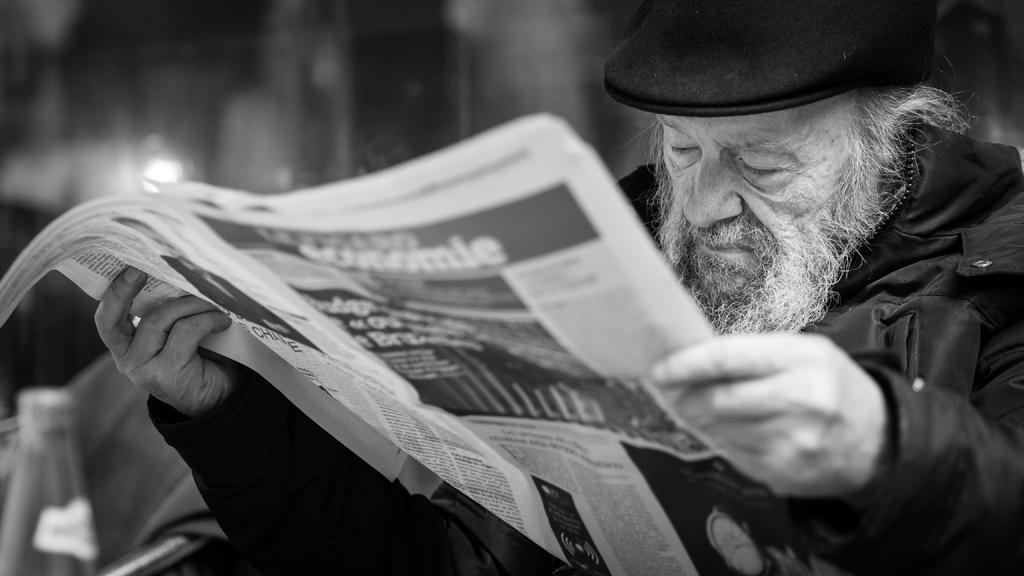Can you describe this image briefly? In this image I can see a person holding a paper and wearing a black color dress and wearing a black color cap on his head and visible on the right side. 